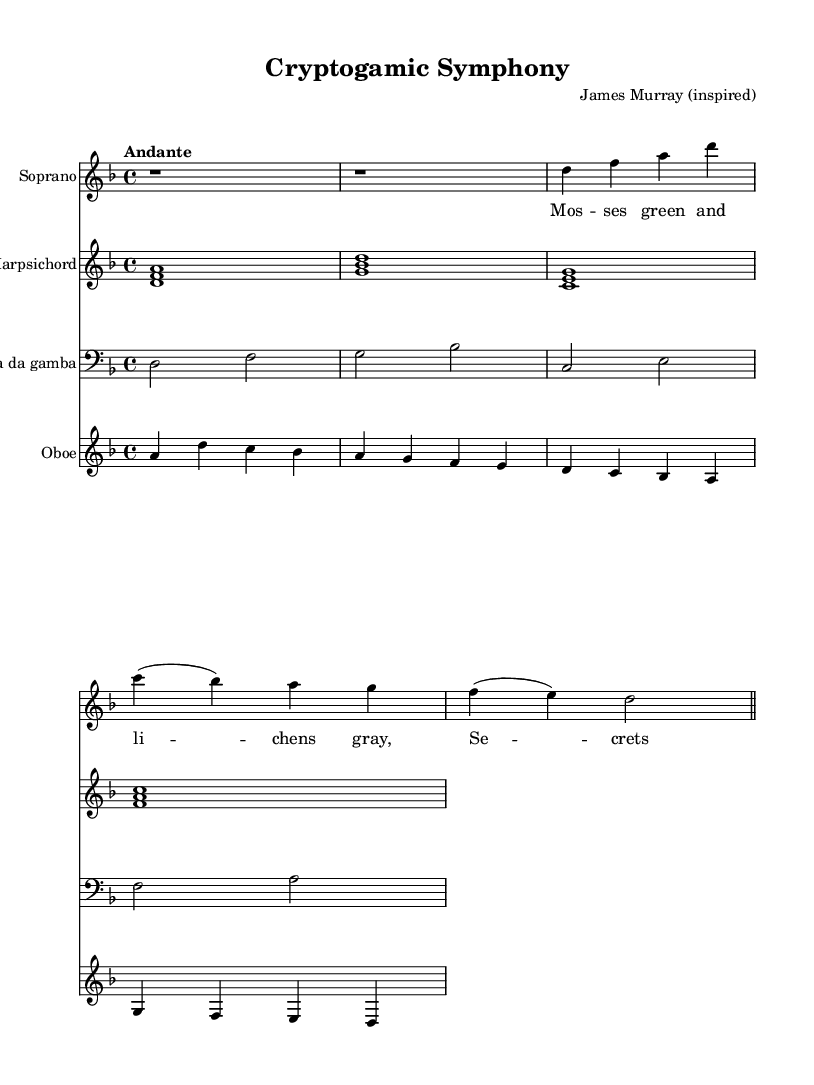What is the key signature of this music? The key signature is indicated by the number of sharps or flats at the beginning of the staff. In this case, there are no sharps or flats, which means the key signature is D minor.
Answer: D minor What is the time signature of this music? The time signature is found at the beginning of the piece, represented by two numbers stacked on top of each other. Here, it shows 4/4, meaning there are four beats in a measure.
Answer: 4/4 What is the tempo marking of this music? The tempo marking is indicated at the beginning under the global settings. The term "Andante" suggests a moderate tempo, typically around 76-108 beats per minute.
Answer: Andante How many measures are present in the soprano part? To find the number of measures, we can count the bar lines in the soprano part. There are four distinct measures indicated by the bar lines separating them.
Answer: 4 What instruments are featured in this cantata? The instruments included are listed at the beginning of their respective staves. They consist of Soprano, Harpsichord, Viola da Gamba, and Oboe, making a total of four instruments.
Answer: Soprano, Harpsichord, Viola da Gamba, Oboe What type of vocal form is represented by the soprano part in this cantata? The soprano part includes a Recitative and an Aria, as indicated by their labels in the score. A Recitative is typically more speech-like, while an Aria is more melodic and structured.
Answer: Recitative and Aria What is the lyrical theme of this cantata? The lyrics reflect themes related to cryptogams and moss, as stated in the title "Cryptogamic Symphony." The nature-inspired lyrics express an admiration for hidden natural beauty.
Answer: Cryptogams and moss 